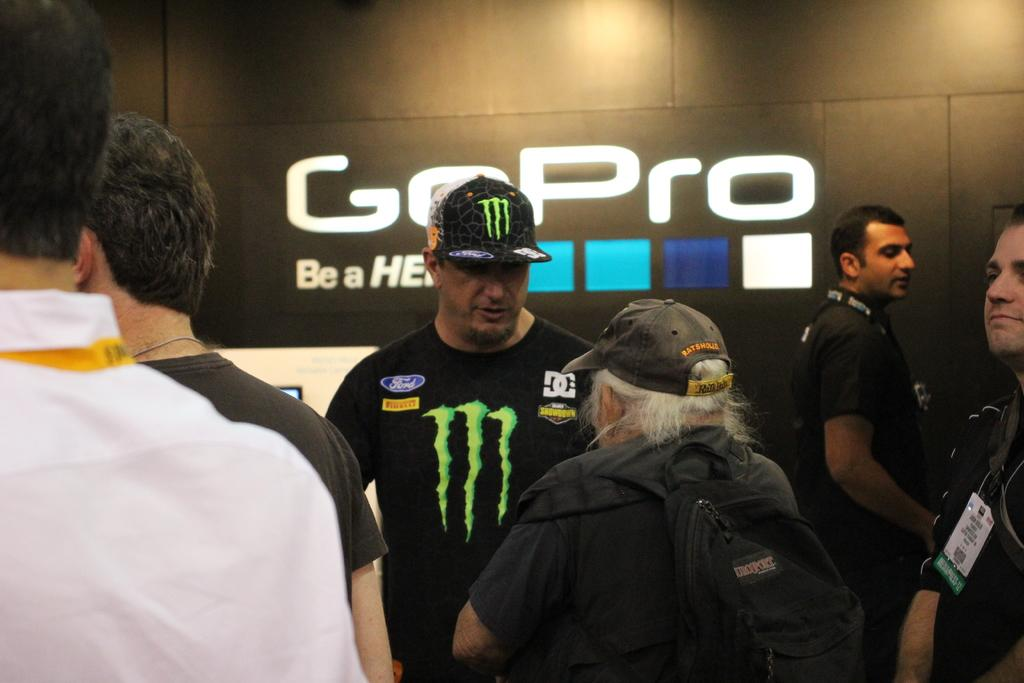<image>
Provide a brief description of the given image. A group of guys are standing around a GoPro advertisement, including a man with Ford on his shirt. 